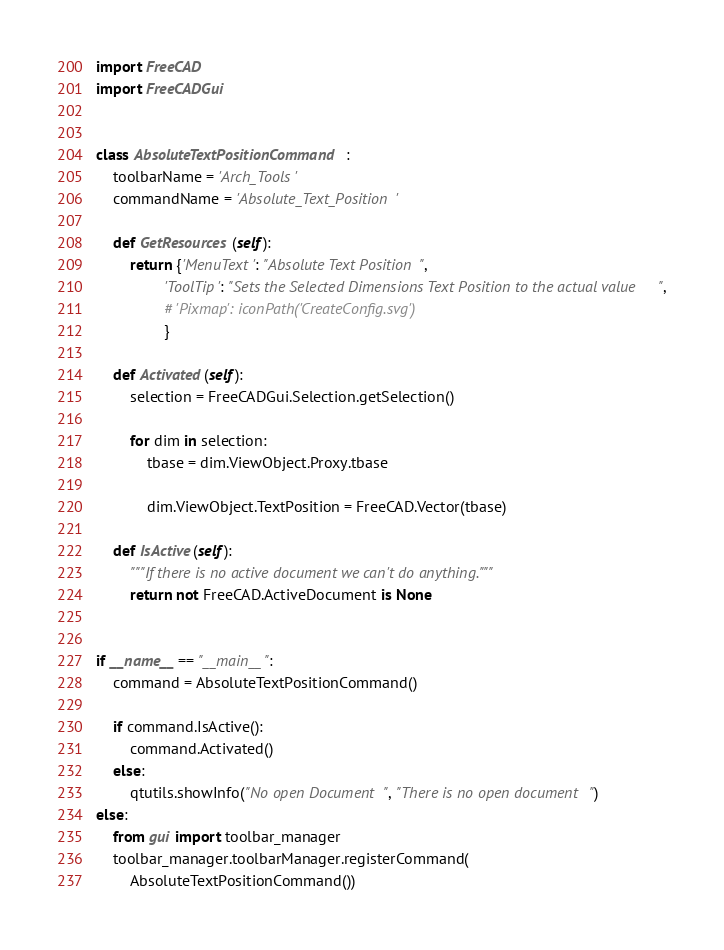Convert code to text. <code><loc_0><loc_0><loc_500><loc_500><_Python_>import FreeCAD
import FreeCADGui


class AbsoluteTextPositionCommand:
    toolbarName = 'Arch_Tools'
    commandName = 'Absolute_Text_Position'

    def GetResources(self):
        return {'MenuText': "Absolute Text Position",
                'ToolTip': "Sets the Selected Dimensions Text Position to the actual value",
                # 'Pixmap': iconPath('CreateConfig.svg')
                }

    def Activated(self):
        selection = FreeCADGui.Selection.getSelection()

        for dim in selection:
            tbase = dim.ViewObject.Proxy.tbase

            dim.ViewObject.TextPosition = FreeCAD.Vector(tbase)

    def IsActive(self):
        """If there is no active document we can't do anything."""
        return not FreeCAD.ActiveDocument is None


if __name__ == "__main__":
    command = AbsoluteTextPositionCommand()

    if command.IsActive():
        command.Activated()
    else:
        qtutils.showInfo("No open Document", "There is no open document")
else:
    from gui import toolbar_manager
    toolbar_manager.toolbarManager.registerCommand(
        AbsoluteTextPositionCommand())
</code> 